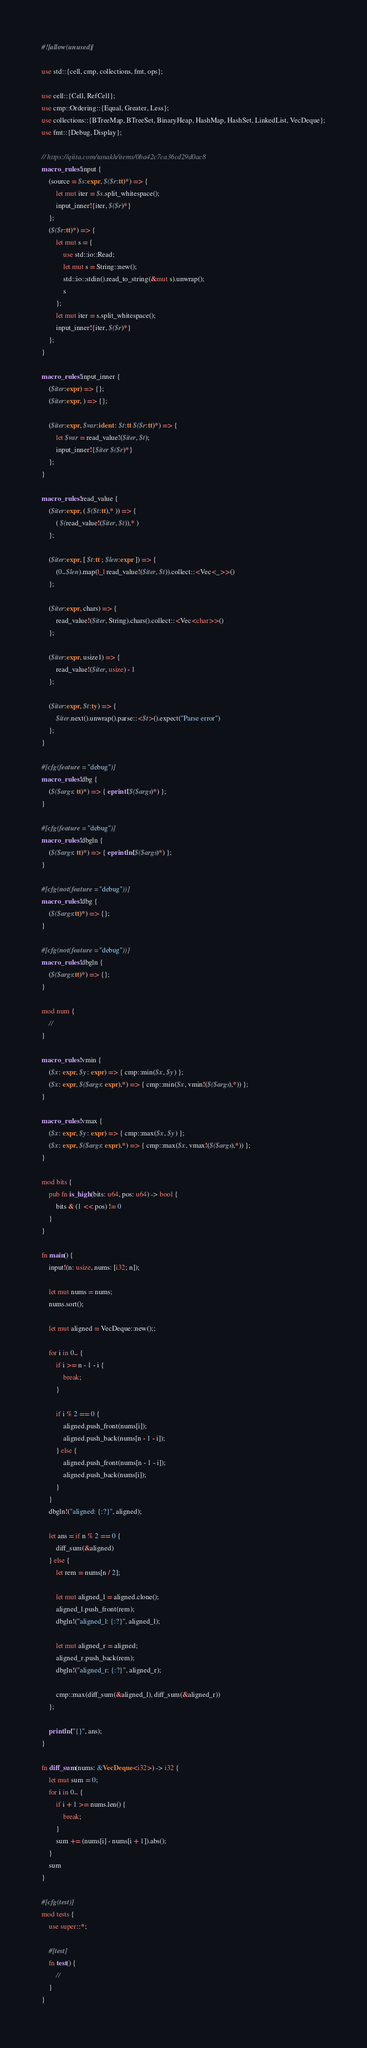Convert code to text. <code><loc_0><loc_0><loc_500><loc_500><_Rust_>#![allow(unused)]

use std::{cell, cmp, collections, fmt, ops};

use cell::{Cell, RefCell};
use cmp::Ordering::{Equal, Greater, Less};
use collections::{BTreeMap, BTreeSet, BinaryHeap, HashMap, HashSet, LinkedList, VecDeque};
use fmt::{Debug, Display};

// https://qiita.com/tanakh/items/0ba42c7ca36cd29d0ac8
macro_rules! input {
    (source = $s:expr, $($r:tt)*) => {
        let mut iter = $s.split_whitespace();
        input_inner!{iter, $($r)*}
    };
    ($($r:tt)*) => {
        let mut s = {
            use std::io::Read;
            let mut s = String::new();
            std::io::stdin().read_to_string(&mut s).unwrap();
            s
        };
        let mut iter = s.split_whitespace();
        input_inner!{iter, $($r)*}
    };
}

macro_rules! input_inner {
    ($iter:expr) => {};
    ($iter:expr, ) => {};

    ($iter:expr, $var:ident : $t:tt $($r:tt)*) => {
        let $var = read_value!($iter, $t);
        input_inner!{$iter $($r)*}
    };
}

macro_rules! read_value {
    ($iter:expr, ( $($t:tt),* )) => {
        ( $(read_value!($iter, $t)),* )
    };

    ($iter:expr, [ $t:tt ; $len:expr ]) => {
        (0..$len).map(|_| read_value!($iter, $t)).collect::<Vec<_>>()
    };

    ($iter:expr, chars) => {
        read_value!($iter, String).chars().collect::<Vec<char>>()
    };

    ($iter:expr, usize1) => {
        read_value!($iter, usize) - 1
    };

    ($iter:expr, $t:ty) => {
        $iter.next().unwrap().parse::<$t>().expect("Parse error")
    };
}

#[cfg(feature = "debug")]
macro_rules! dbg {
    ($($args: tt)*) => { eprint!($($args)*) };
}

#[cfg(feature = "debug")]
macro_rules! dbgln {
    ($($args: tt)*) => { eprintln!($($args)*) };
}

#[cfg(not(feature = "debug"))]
macro_rules! dbg {
    ($($args:tt)*) => {};
}

#[cfg(not(feature = "debug"))]
macro_rules! dbgln {
    ($($args:tt)*) => {};
}

mod num {
    //
}

macro_rules! vmin {
    ($x: expr, $y: expr) => { cmp::min($x, $y) };
    ($x: expr, $($args: expr),*) => { cmp::min($x, vmin!($($args),*)) };
}

macro_rules! vmax {
    ($x: expr, $y: expr) => { cmp::max($x, $y) };
    ($x: expr, $($args: expr),*) => { cmp::max($x, vmax!($($args),*)) };
}

mod bits {
    pub fn is_high(bits: u64, pos: u64) -> bool {
        bits & (1 << pos) != 0
    }
}

fn main() {
    input!(n: usize, nums: [i32; n]);

    let mut nums = nums;
    nums.sort();

    let mut aligned = VecDeque::new();;

    for i in 0.. {
        if i >= n - 1 - i {
            break;
        }

        if i % 2 == 0 {
            aligned.push_front(nums[i]);
            aligned.push_back(nums[n - 1 - i]);
        } else {
            aligned.push_front(nums[n - 1 - i]);
            aligned.push_back(nums[i]);
        }
    }
    dbgln!("aligned: {:?}", aligned);

    let ans = if n % 2 == 0 {
        diff_sum(&aligned)
    } else {
        let rem = nums[n / 2];

        let mut aligned_l = aligned.clone();
        aligned_l.push_front(rem);
        dbgln!("aligned_l: {:?}", aligned_l);

        let mut aligned_r = aligned;
        aligned_r.push_back(rem);
        dbgln!("aligned_r: {:?}", aligned_r);

        cmp::max(diff_sum(&aligned_l), diff_sum(&aligned_r))
    };

    println!("{}", ans);
}

fn diff_sum(nums: &VecDeque<i32>) -> i32 {
    let mut sum = 0;
    for i in 0.. {
        if i + 1 >= nums.len() {
            break;
        }
        sum += (nums[i] - nums[i + 1]).abs();
    }
    sum
}

#[cfg(test)]
mod tests {
    use super::*;

    #[test]
    fn test() {
        //
    }
}
</code> 